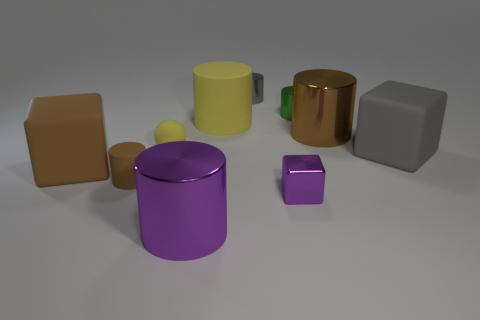Subtract all yellow cylinders. How many cylinders are left? 5 Subtract all large cubes. How many cubes are left? 1 Subtract all gray cylinders. Subtract all blue cubes. How many cylinders are left? 5 Subtract all blocks. How many objects are left? 7 Add 9 green shiny spheres. How many green shiny spheres exist? 9 Subtract 0 red balls. How many objects are left? 10 Subtract all small metal cubes. Subtract all small brown rubber cylinders. How many objects are left? 8 Add 2 big gray blocks. How many big gray blocks are left? 3 